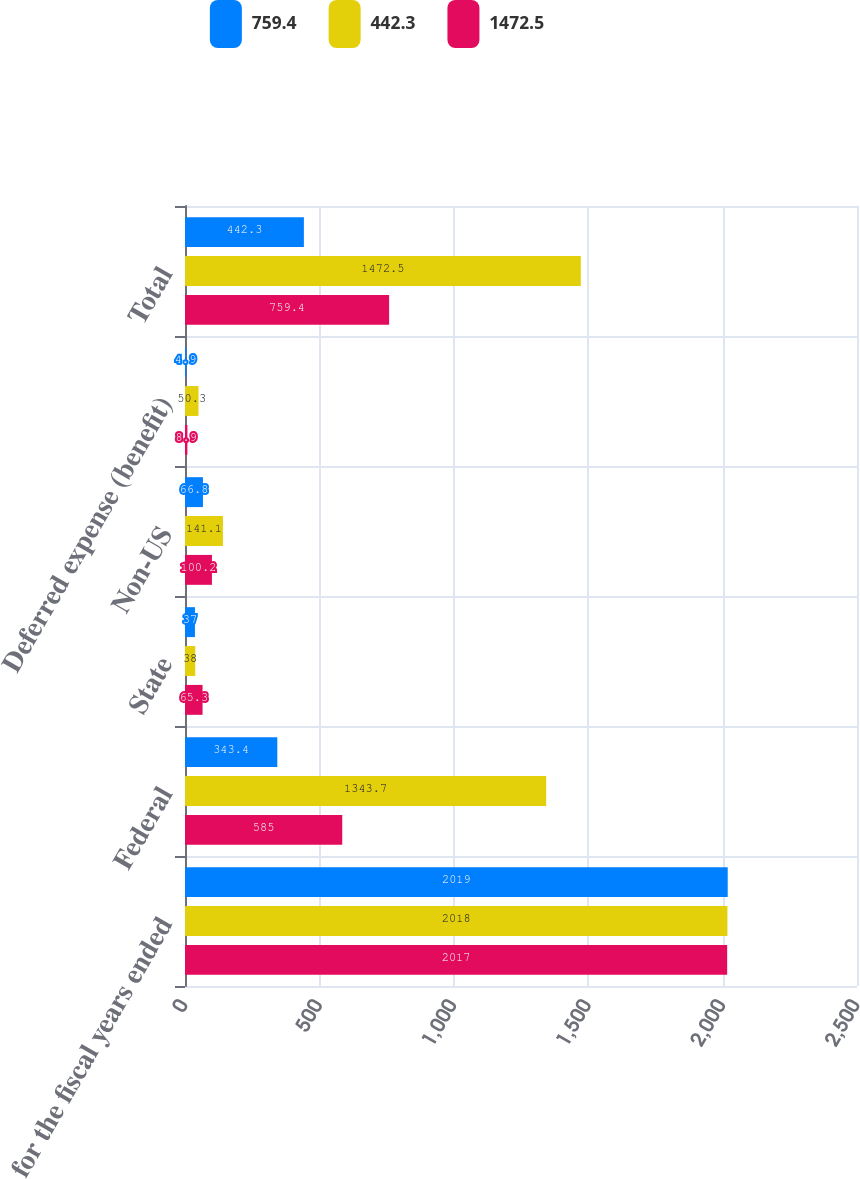<chart> <loc_0><loc_0><loc_500><loc_500><stacked_bar_chart><ecel><fcel>for the fiscal years ended<fcel>Federal<fcel>State<fcel>Non-US<fcel>Deferred expense (benefit)<fcel>Total<nl><fcel>759.4<fcel>2019<fcel>343.4<fcel>37<fcel>66.8<fcel>4.9<fcel>442.3<nl><fcel>442.3<fcel>2018<fcel>1343.7<fcel>38<fcel>141.1<fcel>50.3<fcel>1472.5<nl><fcel>1472.5<fcel>2017<fcel>585<fcel>65.3<fcel>100.2<fcel>8.9<fcel>759.4<nl></chart> 